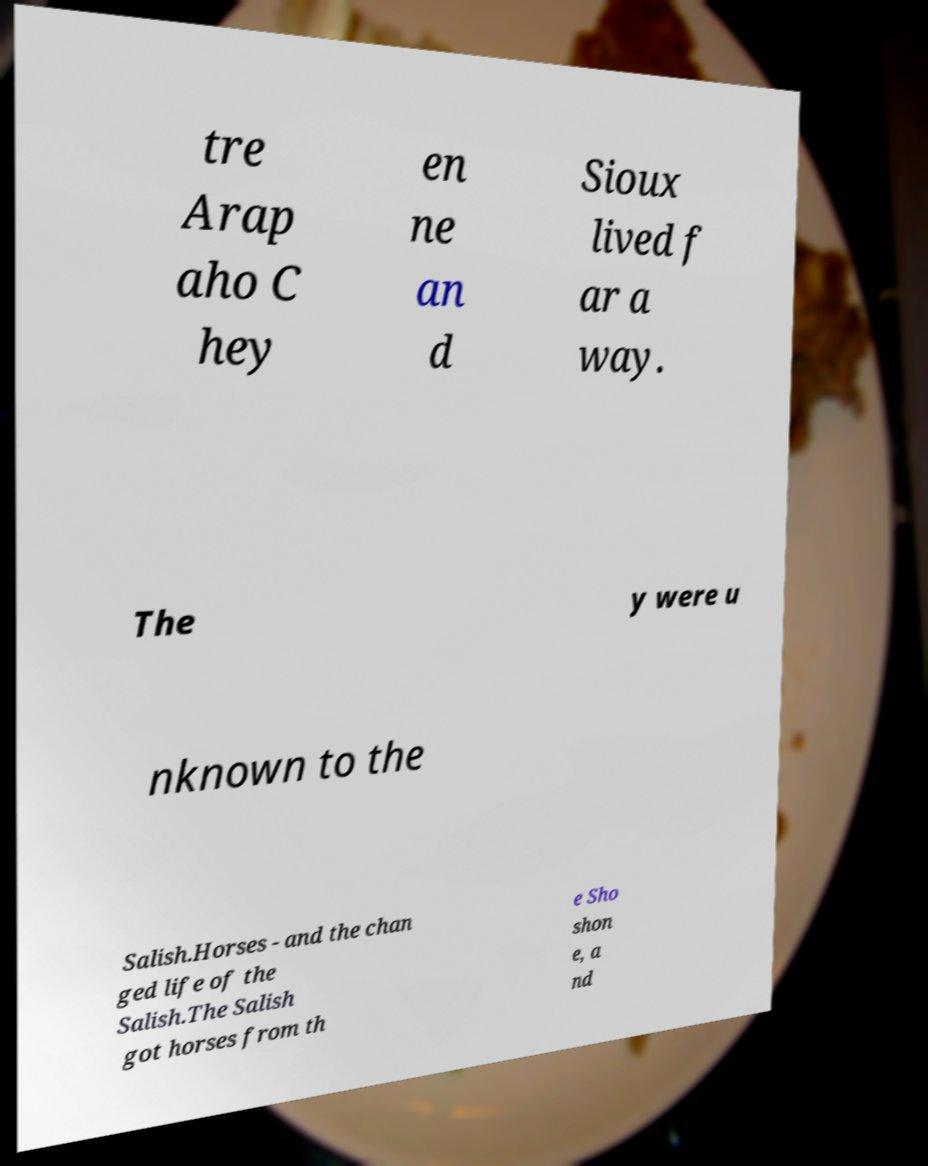What messages or text are displayed in this image? I need them in a readable, typed format. tre Arap aho C hey en ne an d Sioux lived f ar a way. The y were u nknown to the Salish.Horses - and the chan ged life of the Salish.The Salish got horses from th e Sho shon e, a nd 